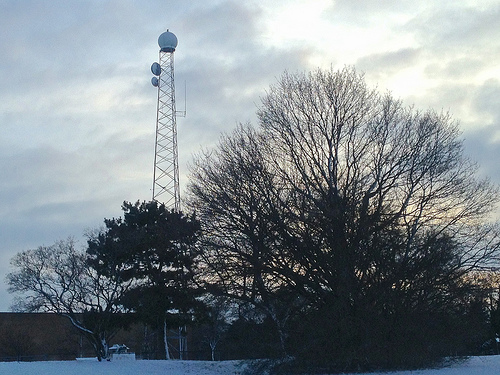<image>
Is there a tower next to the tree? Yes. The tower is positioned adjacent to the tree, located nearby in the same general area. Is there a tower in front of the tree? No. The tower is not in front of the tree. The spatial positioning shows a different relationship between these objects. 